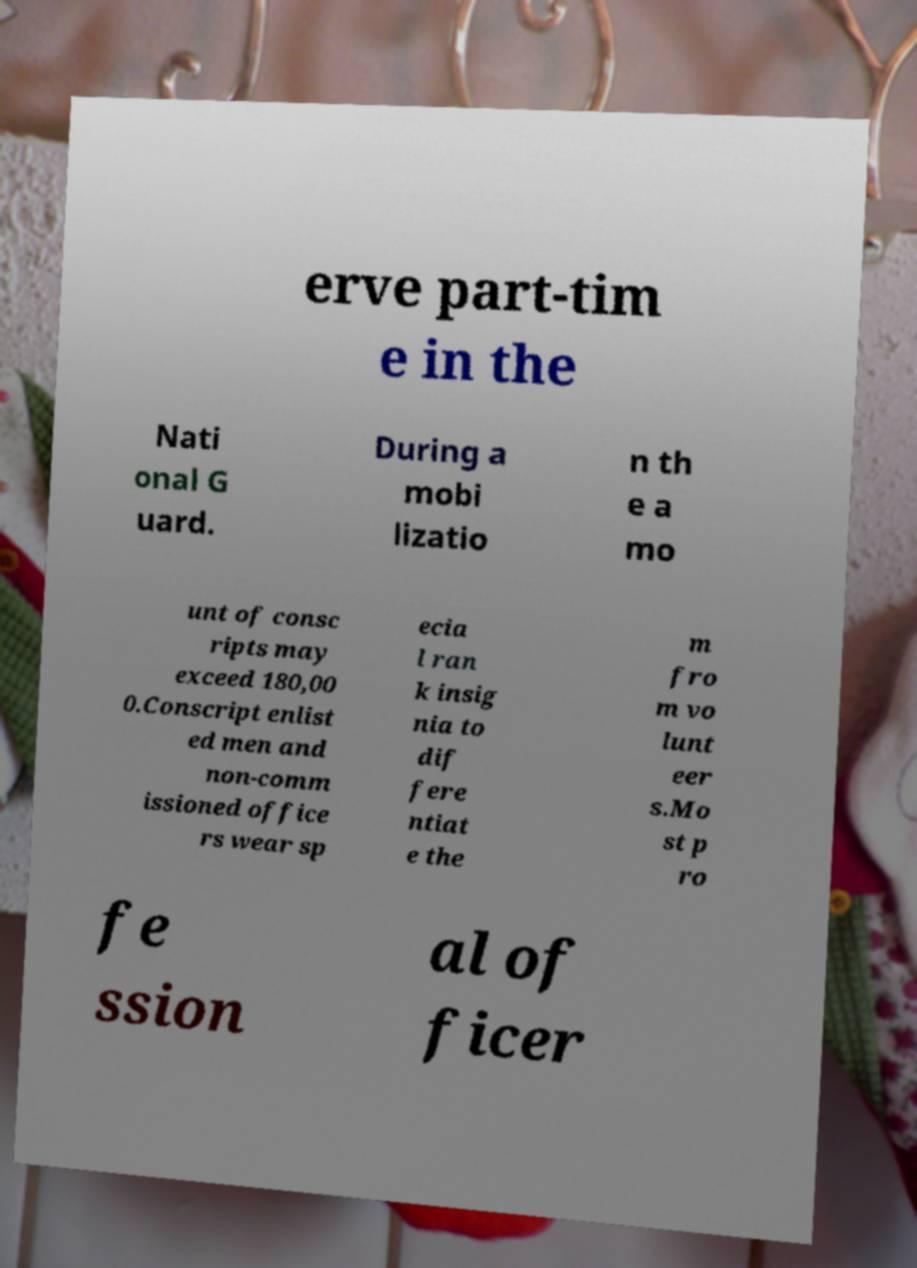Please identify and transcribe the text found in this image. erve part-tim e in the Nati onal G uard. During a mobi lizatio n th e a mo unt of consc ripts may exceed 180,00 0.Conscript enlist ed men and non-comm issioned office rs wear sp ecia l ran k insig nia to dif fere ntiat e the m fro m vo lunt eer s.Mo st p ro fe ssion al of ficer 